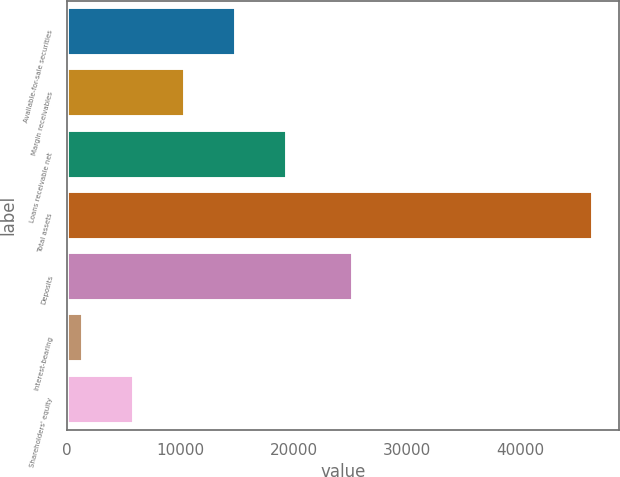Convert chart. <chart><loc_0><loc_0><loc_500><loc_500><bar_chart><fcel>Available-for-sale securities<fcel>Margin receivables<fcel>Loans receivable net<fcel>Total assets<fcel>Deposits<fcel>Interest-bearing<fcel>Shareholders' equity<nl><fcel>14921.2<fcel>10428.1<fcel>19414.3<fcel>46373<fcel>25240.3<fcel>1441.9<fcel>5935.01<nl></chart> 